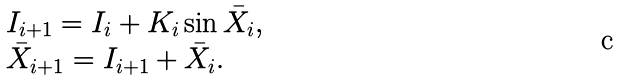Convert formula to latex. <formula><loc_0><loc_0><loc_500><loc_500>\begin{array} l I _ { i + 1 } = I _ { i } + K _ { i } \sin \bar { X } _ { i } , \\ \bar { X } _ { i + 1 } = I _ { i + 1 } + \bar { X } _ { i } . \end{array}</formula> 